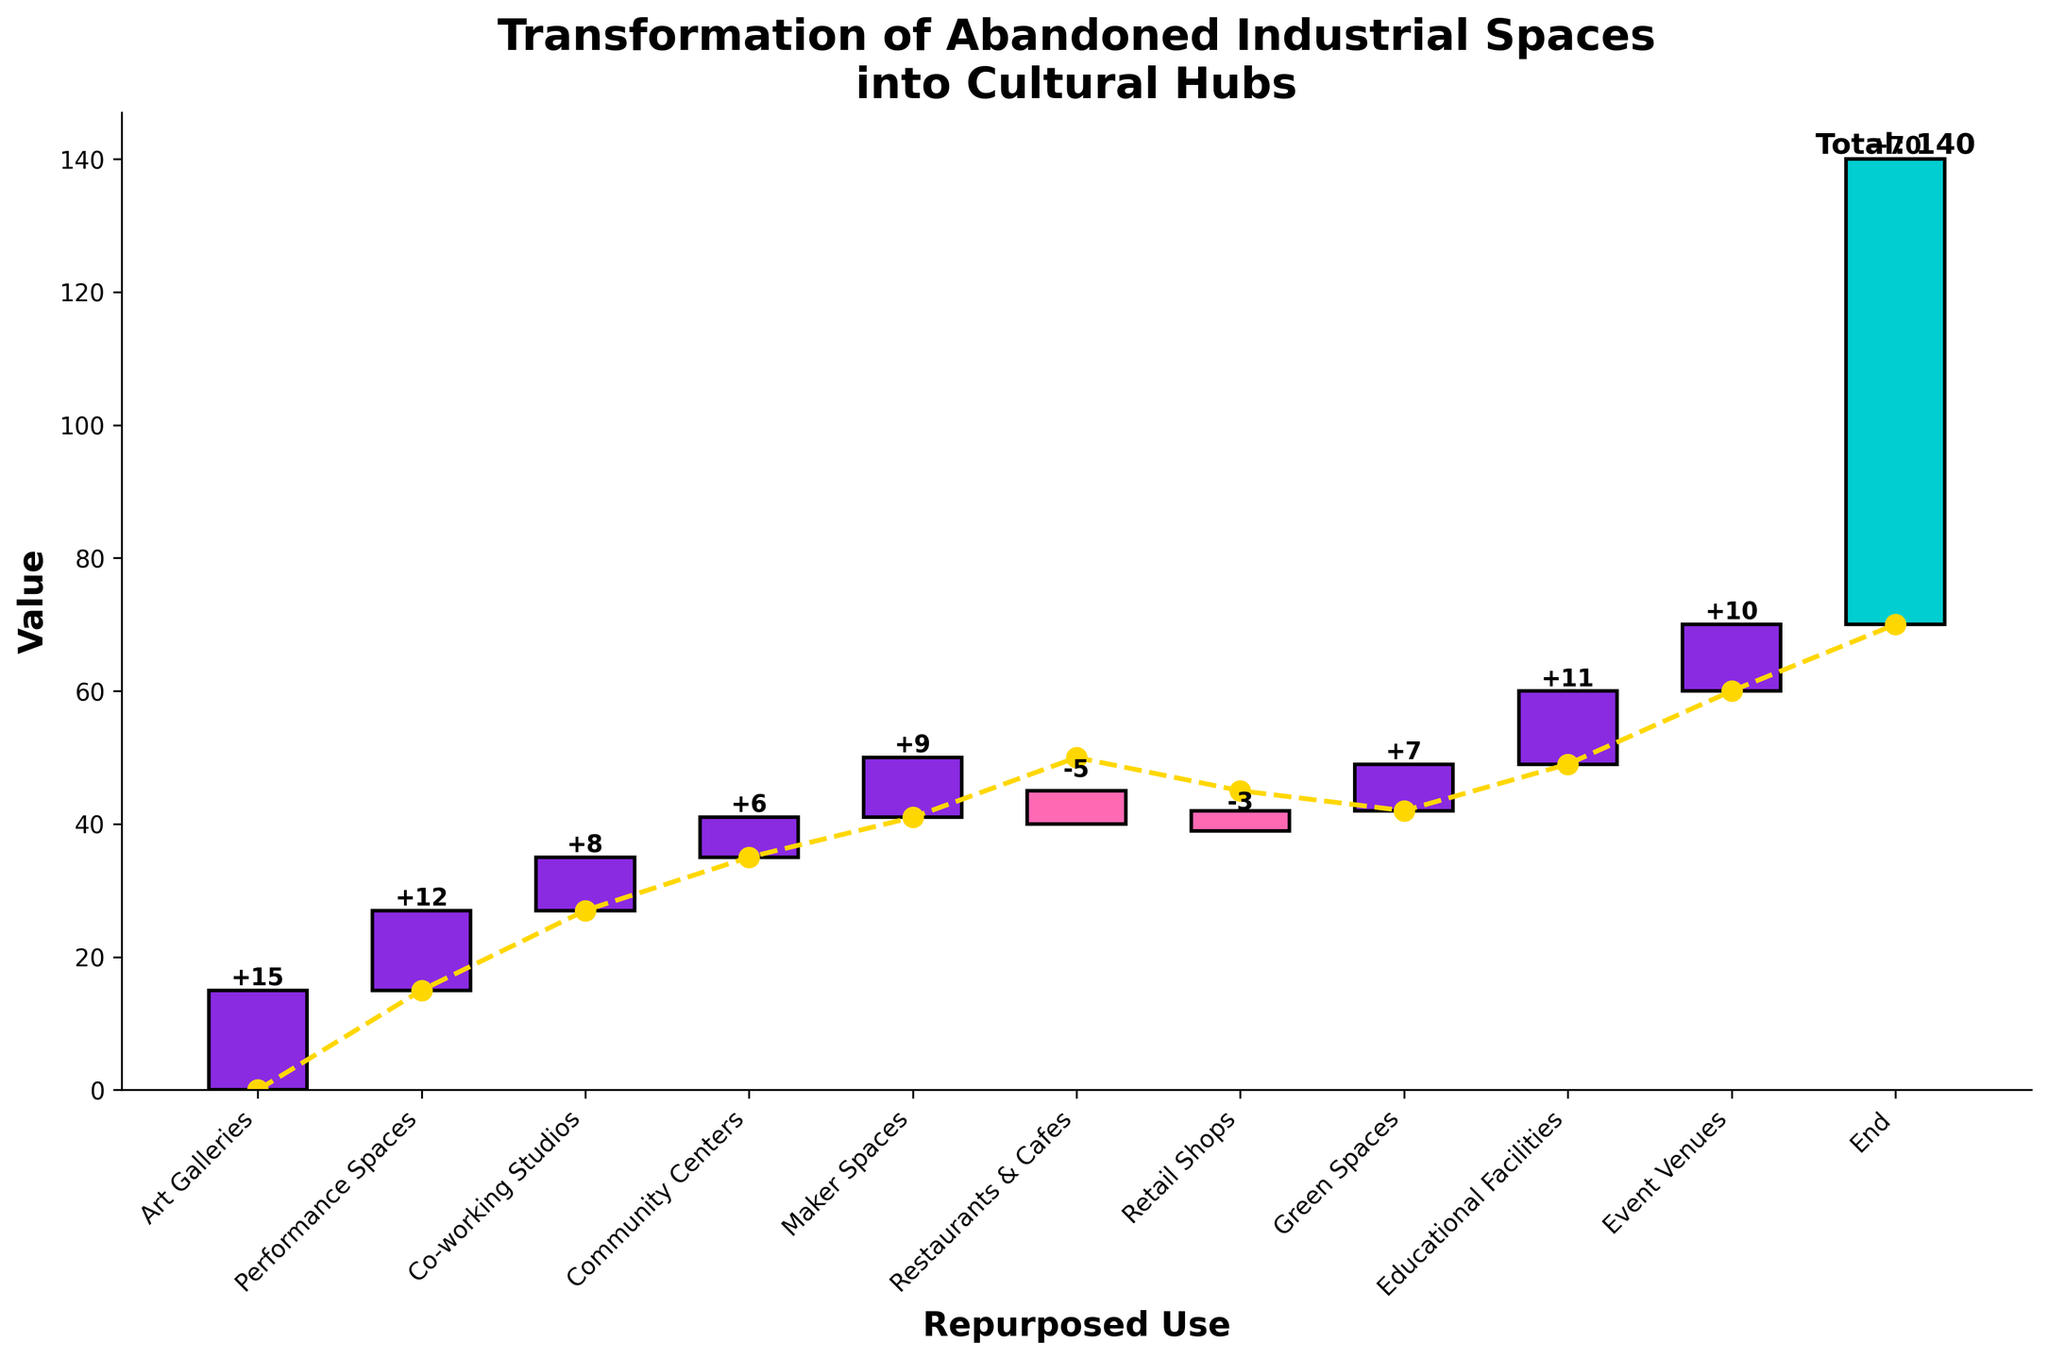what is the title of the figure? The title of the figure is written at the top of the plot in a bold font. It reads "Transformation of Abandoned Industrial Spaces into Cultural Hubs".
Answer: Transformation of Abandoned Industrial Spaces into Cultural Hubs Which category has the highest positive contribution? The category with the highest positive contribution can be identified by looking at the tallest bars above the horizontal axis. The tallest bar corresponds to "Art Galleries" with a value of 15.
Answer: Art Galleries How much is the cumulative value before the category with the largest negative contribution? The largest negative contribution bar is labeled "Restaurants & Cafes" with a value of -5. To find the cumulative value before this category, sum the previous values (15 + 12 + 8 + 6 + 9). This gives 50.
Answer: 50 Which categories have negative contributions, and what are their values? The negative contributions can be identified by looking at the bars that extend below the horizontal axis. The categories with negative values are "Restaurants & Cafes" and "Retail Shops", with values of -5 and -3 respectively.
Answer: Restaurants & Cafes: -5, Retail Shops: -3 What is the cumulative total value at the end? The cumulative total value at the end is represented by the last bar labeled "End". It has a value of 70.
Answer: 70 How many categories were analyzed for their contribution, excluding the start and end points? The categories analyzed can be counted by excluding the "Start" and "End" points. There are 10 categories in total.
Answer: 10 What is the cumulative value immediately after the "Art Galleries"? To find the cumulative value immediately after "Art Galleries," sum the values from the start to this category (0 + 15). This gives a cumulative value of 15.
Answer: 15 Which category has just one less positive contribution compared to the highest category? The category "Performance Spaces" has a value of 12, which is just 3 units less than "Art Galleries" with a value of 15.
Answer: Performance Spaces What is the net change contributed by "Green Spaces" and "Educational Facilities"? The net change contributed by "Green Spaces" and "Educational Facilities" is the sum of their values (7 + 11) which gives a net change of 18.
Answer: 18 What visual element connects the data points on the figure? The connecting lines in the figure are represented by dashed yellow lines with circular markers, linking each cumulative value from one category to the next.
Answer: Dashed yellow lines 